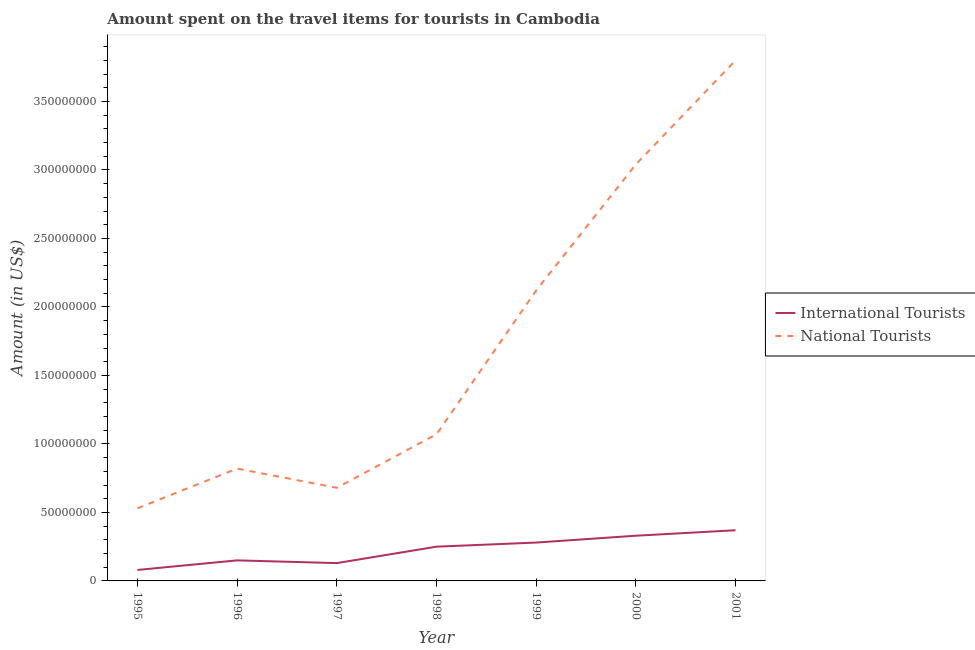How many different coloured lines are there?
Keep it short and to the point. 2. What is the amount spent on travel items of national tourists in 2001?
Offer a very short reply. 3.80e+08. Across all years, what is the maximum amount spent on travel items of national tourists?
Provide a succinct answer. 3.80e+08. Across all years, what is the minimum amount spent on travel items of international tourists?
Provide a short and direct response. 8.00e+06. In which year was the amount spent on travel items of national tourists maximum?
Offer a terse response. 2001. In which year was the amount spent on travel items of international tourists minimum?
Offer a very short reply. 1995. What is the total amount spent on travel items of national tourists in the graph?
Keep it short and to the point. 1.21e+09. What is the difference between the amount spent on travel items of international tourists in 1996 and that in 2000?
Keep it short and to the point. -1.80e+07. What is the difference between the amount spent on travel items of national tourists in 1998 and the amount spent on travel items of international tourists in 1996?
Your answer should be very brief. 9.20e+07. What is the average amount spent on travel items of international tourists per year?
Provide a succinct answer. 2.27e+07. In the year 1999, what is the difference between the amount spent on travel items of international tourists and amount spent on travel items of national tourists?
Ensure brevity in your answer.  -1.84e+08. What is the ratio of the amount spent on travel items of international tourists in 1997 to that in 2001?
Your response must be concise. 0.35. Is the amount spent on travel items of international tourists in 1995 less than that in 1998?
Ensure brevity in your answer.  Yes. Is the difference between the amount spent on travel items of international tourists in 1997 and 2001 greater than the difference between the amount spent on travel items of national tourists in 1997 and 2001?
Ensure brevity in your answer.  Yes. What is the difference between the highest and the second highest amount spent on travel items of international tourists?
Ensure brevity in your answer.  4.00e+06. What is the difference between the highest and the lowest amount spent on travel items of national tourists?
Provide a succinct answer. 3.27e+08. In how many years, is the amount spent on travel items of national tourists greater than the average amount spent on travel items of national tourists taken over all years?
Keep it short and to the point. 3. Does the amount spent on travel items of national tourists monotonically increase over the years?
Your answer should be very brief. No. Is the amount spent on travel items of international tourists strictly greater than the amount spent on travel items of national tourists over the years?
Your response must be concise. No. Is the amount spent on travel items of international tourists strictly less than the amount spent on travel items of national tourists over the years?
Your answer should be compact. Yes. How many lines are there?
Provide a succinct answer. 2. How many years are there in the graph?
Your response must be concise. 7. Where does the legend appear in the graph?
Your answer should be compact. Center right. How many legend labels are there?
Keep it short and to the point. 2. What is the title of the graph?
Ensure brevity in your answer.  Amount spent on the travel items for tourists in Cambodia. Does "From Government" appear as one of the legend labels in the graph?
Offer a terse response. No. What is the label or title of the X-axis?
Ensure brevity in your answer.  Year. What is the label or title of the Y-axis?
Make the answer very short. Amount (in US$). What is the Amount (in US$) of National Tourists in 1995?
Give a very brief answer. 5.30e+07. What is the Amount (in US$) in International Tourists in 1996?
Your answer should be very brief. 1.50e+07. What is the Amount (in US$) in National Tourists in 1996?
Ensure brevity in your answer.  8.20e+07. What is the Amount (in US$) of International Tourists in 1997?
Give a very brief answer. 1.30e+07. What is the Amount (in US$) of National Tourists in 1997?
Your answer should be very brief. 6.80e+07. What is the Amount (in US$) in International Tourists in 1998?
Your response must be concise. 2.50e+07. What is the Amount (in US$) in National Tourists in 1998?
Provide a short and direct response. 1.07e+08. What is the Amount (in US$) in International Tourists in 1999?
Provide a short and direct response. 2.80e+07. What is the Amount (in US$) of National Tourists in 1999?
Keep it short and to the point. 2.12e+08. What is the Amount (in US$) of International Tourists in 2000?
Your answer should be very brief. 3.30e+07. What is the Amount (in US$) in National Tourists in 2000?
Your answer should be very brief. 3.04e+08. What is the Amount (in US$) of International Tourists in 2001?
Make the answer very short. 3.70e+07. What is the Amount (in US$) of National Tourists in 2001?
Make the answer very short. 3.80e+08. Across all years, what is the maximum Amount (in US$) of International Tourists?
Your response must be concise. 3.70e+07. Across all years, what is the maximum Amount (in US$) in National Tourists?
Keep it short and to the point. 3.80e+08. Across all years, what is the minimum Amount (in US$) in International Tourists?
Your answer should be very brief. 8.00e+06. Across all years, what is the minimum Amount (in US$) of National Tourists?
Keep it short and to the point. 5.30e+07. What is the total Amount (in US$) of International Tourists in the graph?
Keep it short and to the point. 1.59e+08. What is the total Amount (in US$) in National Tourists in the graph?
Your response must be concise. 1.21e+09. What is the difference between the Amount (in US$) of International Tourists in 1995 and that in 1996?
Your response must be concise. -7.00e+06. What is the difference between the Amount (in US$) in National Tourists in 1995 and that in 1996?
Give a very brief answer. -2.90e+07. What is the difference between the Amount (in US$) in International Tourists in 1995 and that in 1997?
Make the answer very short. -5.00e+06. What is the difference between the Amount (in US$) of National Tourists in 1995 and that in 1997?
Ensure brevity in your answer.  -1.50e+07. What is the difference between the Amount (in US$) in International Tourists in 1995 and that in 1998?
Provide a succinct answer. -1.70e+07. What is the difference between the Amount (in US$) in National Tourists in 1995 and that in 1998?
Ensure brevity in your answer.  -5.40e+07. What is the difference between the Amount (in US$) of International Tourists in 1995 and that in 1999?
Ensure brevity in your answer.  -2.00e+07. What is the difference between the Amount (in US$) in National Tourists in 1995 and that in 1999?
Ensure brevity in your answer.  -1.59e+08. What is the difference between the Amount (in US$) of International Tourists in 1995 and that in 2000?
Give a very brief answer. -2.50e+07. What is the difference between the Amount (in US$) of National Tourists in 1995 and that in 2000?
Provide a short and direct response. -2.51e+08. What is the difference between the Amount (in US$) of International Tourists in 1995 and that in 2001?
Give a very brief answer. -2.90e+07. What is the difference between the Amount (in US$) of National Tourists in 1995 and that in 2001?
Your answer should be very brief. -3.27e+08. What is the difference between the Amount (in US$) of International Tourists in 1996 and that in 1997?
Offer a terse response. 2.00e+06. What is the difference between the Amount (in US$) in National Tourists in 1996 and that in 1997?
Keep it short and to the point. 1.40e+07. What is the difference between the Amount (in US$) in International Tourists in 1996 and that in 1998?
Provide a succinct answer. -1.00e+07. What is the difference between the Amount (in US$) in National Tourists in 1996 and that in 1998?
Give a very brief answer. -2.50e+07. What is the difference between the Amount (in US$) in International Tourists in 1996 and that in 1999?
Give a very brief answer. -1.30e+07. What is the difference between the Amount (in US$) in National Tourists in 1996 and that in 1999?
Make the answer very short. -1.30e+08. What is the difference between the Amount (in US$) in International Tourists in 1996 and that in 2000?
Your response must be concise. -1.80e+07. What is the difference between the Amount (in US$) of National Tourists in 1996 and that in 2000?
Provide a short and direct response. -2.22e+08. What is the difference between the Amount (in US$) of International Tourists in 1996 and that in 2001?
Offer a very short reply. -2.20e+07. What is the difference between the Amount (in US$) in National Tourists in 1996 and that in 2001?
Your answer should be compact. -2.98e+08. What is the difference between the Amount (in US$) of International Tourists in 1997 and that in 1998?
Ensure brevity in your answer.  -1.20e+07. What is the difference between the Amount (in US$) in National Tourists in 1997 and that in 1998?
Give a very brief answer. -3.90e+07. What is the difference between the Amount (in US$) of International Tourists in 1997 and that in 1999?
Keep it short and to the point. -1.50e+07. What is the difference between the Amount (in US$) of National Tourists in 1997 and that in 1999?
Your answer should be very brief. -1.44e+08. What is the difference between the Amount (in US$) of International Tourists in 1997 and that in 2000?
Give a very brief answer. -2.00e+07. What is the difference between the Amount (in US$) of National Tourists in 1997 and that in 2000?
Provide a succinct answer. -2.36e+08. What is the difference between the Amount (in US$) in International Tourists in 1997 and that in 2001?
Your answer should be very brief. -2.40e+07. What is the difference between the Amount (in US$) in National Tourists in 1997 and that in 2001?
Ensure brevity in your answer.  -3.12e+08. What is the difference between the Amount (in US$) in National Tourists in 1998 and that in 1999?
Ensure brevity in your answer.  -1.05e+08. What is the difference between the Amount (in US$) of International Tourists in 1998 and that in 2000?
Your answer should be very brief. -8.00e+06. What is the difference between the Amount (in US$) in National Tourists in 1998 and that in 2000?
Give a very brief answer. -1.97e+08. What is the difference between the Amount (in US$) in International Tourists in 1998 and that in 2001?
Your answer should be very brief. -1.20e+07. What is the difference between the Amount (in US$) in National Tourists in 1998 and that in 2001?
Your response must be concise. -2.73e+08. What is the difference between the Amount (in US$) of International Tourists in 1999 and that in 2000?
Give a very brief answer. -5.00e+06. What is the difference between the Amount (in US$) in National Tourists in 1999 and that in 2000?
Keep it short and to the point. -9.20e+07. What is the difference between the Amount (in US$) of International Tourists in 1999 and that in 2001?
Provide a succinct answer. -9.00e+06. What is the difference between the Amount (in US$) of National Tourists in 1999 and that in 2001?
Keep it short and to the point. -1.68e+08. What is the difference between the Amount (in US$) in National Tourists in 2000 and that in 2001?
Offer a terse response. -7.60e+07. What is the difference between the Amount (in US$) of International Tourists in 1995 and the Amount (in US$) of National Tourists in 1996?
Provide a short and direct response. -7.40e+07. What is the difference between the Amount (in US$) of International Tourists in 1995 and the Amount (in US$) of National Tourists in 1997?
Provide a short and direct response. -6.00e+07. What is the difference between the Amount (in US$) of International Tourists in 1995 and the Amount (in US$) of National Tourists in 1998?
Offer a very short reply. -9.90e+07. What is the difference between the Amount (in US$) of International Tourists in 1995 and the Amount (in US$) of National Tourists in 1999?
Ensure brevity in your answer.  -2.04e+08. What is the difference between the Amount (in US$) in International Tourists in 1995 and the Amount (in US$) in National Tourists in 2000?
Provide a succinct answer. -2.96e+08. What is the difference between the Amount (in US$) of International Tourists in 1995 and the Amount (in US$) of National Tourists in 2001?
Your answer should be compact. -3.72e+08. What is the difference between the Amount (in US$) in International Tourists in 1996 and the Amount (in US$) in National Tourists in 1997?
Your answer should be very brief. -5.30e+07. What is the difference between the Amount (in US$) in International Tourists in 1996 and the Amount (in US$) in National Tourists in 1998?
Your answer should be very brief. -9.20e+07. What is the difference between the Amount (in US$) of International Tourists in 1996 and the Amount (in US$) of National Tourists in 1999?
Make the answer very short. -1.97e+08. What is the difference between the Amount (in US$) in International Tourists in 1996 and the Amount (in US$) in National Tourists in 2000?
Your response must be concise. -2.89e+08. What is the difference between the Amount (in US$) in International Tourists in 1996 and the Amount (in US$) in National Tourists in 2001?
Keep it short and to the point. -3.65e+08. What is the difference between the Amount (in US$) in International Tourists in 1997 and the Amount (in US$) in National Tourists in 1998?
Provide a short and direct response. -9.40e+07. What is the difference between the Amount (in US$) of International Tourists in 1997 and the Amount (in US$) of National Tourists in 1999?
Keep it short and to the point. -1.99e+08. What is the difference between the Amount (in US$) of International Tourists in 1997 and the Amount (in US$) of National Tourists in 2000?
Ensure brevity in your answer.  -2.91e+08. What is the difference between the Amount (in US$) in International Tourists in 1997 and the Amount (in US$) in National Tourists in 2001?
Make the answer very short. -3.67e+08. What is the difference between the Amount (in US$) in International Tourists in 1998 and the Amount (in US$) in National Tourists in 1999?
Provide a succinct answer. -1.87e+08. What is the difference between the Amount (in US$) in International Tourists in 1998 and the Amount (in US$) in National Tourists in 2000?
Your response must be concise. -2.79e+08. What is the difference between the Amount (in US$) of International Tourists in 1998 and the Amount (in US$) of National Tourists in 2001?
Your response must be concise. -3.55e+08. What is the difference between the Amount (in US$) in International Tourists in 1999 and the Amount (in US$) in National Tourists in 2000?
Offer a terse response. -2.76e+08. What is the difference between the Amount (in US$) in International Tourists in 1999 and the Amount (in US$) in National Tourists in 2001?
Your answer should be compact. -3.52e+08. What is the difference between the Amount (in US$) of International Tourists in 2000 and the Amount (in US$) of National Tourists in 2001?
Offer a terse response. -3.47e+08. What is the average Amount (in US$) in International Tourists per year?
Offer a terse response. 2.27e+07. What is the average Amount (in US$) of National Tourists per year?
Provide a short and direct response. 1.72e+08. In the year 1995, what is the difference between the Amount (in US$) of International Tourists and Amount (in US$) of National Tourists?
Offer a terse response. -4.50e+07. In the year 1996, what is the difference between the Amount (in US$) in International Tourists and Amount (in US$) in National Tourists?
Your response must be concise. -6.70e+07. In the year 1997, what is the difference between the Amount (in US$) in International Tourists and Amount (in US$) in National Tourists?
Keep it short and to the point. -5.50e+07. In the year 1998, what is the difference between the Amount (in US$) of International Tourists and Amount (in US$) of National Tourists?
Offer a very short reply. -8.20e+07. In the year 1999, what is the difference between the Amount (in US$) in International Tourists and Amount (in US$) in National Tourists?
Your answer should be very brief. -1.84e+08. In the year 2000, what is the difference between the Amount (in US$) of International Tourists and Amount (in US$) of National Tourists?
Your answer should be compact. -2.71e+08. In the year 2001, what is the difference between the Amount (in US$) of International Tourists and Amount (in US$) of National Tourists?
Your answer should be very brief. -3.43e+08. What is the ratio of the Amount (in US$) of International Tourists in 1995 to that in 1996?
Offer a very short reply. 0.53. What is the ratio of the Amount (in US$) of National Tourists in 1995 to that in 1996?
Your answer should be compact. 0.65. What is the ratio of the Amount (in US$) of International Tourists in 1995 to that in 1997?
Ensure brevity in your answer.  0.62. What is the ratio of the Amount (in US$) in National Tourists in 1995 to that in 1997?
Provide a short and direct response. 0.78. What is the ratio of the Amount (in US$) of International Tourists in 1995 to that in 1998?
Your answer should be compact. 0.32. What is the ratio of the Amount (in US$) of National Tourists in 1995 to that in 1998?
Your answer should be very brief. 0.5. What is the ratio of the Amount (in US$) in International Tourists in 1995 to that in 1999?
Offer a very short reply. 0.29. What is the ratio of the Amount (in US$) in National Tourists in 1995 to that in 1999?
Your response must be concise. 0.25. What is the ratio of the Amount (in US$) of International Tourists in 1995 to that in 2000?
Your response must be concise. 0.24. What is the ratio of the Amount (in US$) of National Tourists in 1995 to that in 2000?
Offer a terse response. 0.17. What is the ratio of the Amount (in US$) of International Tourists in 1995 to that in 2001?
Your response must be concise. 0.22. What is the ratio of the Amount (in US$) in National Tourists in 1995 to that in 2001?
Offer a terse response. 0.14. What is the ratio of the Amount (in US$) in International Tourists in 1996 to that in 1997?
Offer a terse response. 1.15. What is the ratio of the Amount (in US$) of National Tourists in 1996 to that in 1997?
Make the answer very short. 1.21. What is the ratio of the Amount (in US$) of National Tourists in 1996 to that in 1998?
Your answer should be compact. 0.77. What is the ratio of the Amount (in US$) of International Tourists in 1996 to that in 1999?
Provide a short and direct response. 0.54. What is the ratio of the Amount (in US$) of National Tourists in 1996 to that in 1999?
Make the answer very short. 0.39. What is the ratio of the Amount (in US$) in International Tourists in 1996 to that in 2000?
Provide a succinct answer. 0.45. What is the ratio of the Amount (in US$) in National Tourists in 1996 to that in 2000?
Provide a short and direct response. 0.27. What is the ratio of the Amount (in US$) in International Tourists in 1996 to that in 2001?
Your answer should be compact. 0.41. What is the ratio of the Amount (in US$) in National Tourists in 1996 to that in 2001?
Offer a terse response. 0.22. What is the ratio of the Amount (in US$) of International Tourists in 1997 to that in 1998?
Give a very brief answer. 0.52. What is the ratio of the Amount (in US$) in National Tourists in 1997 to that in 1998?
Offer a very short reply. 0.64. What is the ratio of the Amount (in US$) in International Tourists in 1997 to that in 1999?
Give a very brief answer. 0.46. What is the ratio of the Amount (in US$) of National Tourists in 1997 to that in 1999?
Provide a short and direct response. 0.32. What is the ratio of the Amount (in US$) in International Tourists in 1997 to that in 2000?
Offer a terse response. 0.39. What is the ratio of the Amount (in US$) of National Tourists in 1997 to that in 2000?
Offer a terse response. 0.22. What is the ratio of the Amount (in US$) in International Tourists in 1997 to that in 2001?
Your response must be concise. 0.35. What is the ratio of the Amount (in US$) in National Tourists in 1997 to that in 2001?
Your answer should be compact. 0.18. What is the ratio of the Amount (in US$) of International Tourists in 1998 to that in 1999?
Give a very brief answer. 0.89. What is the ratio of the Amount (in US$) of National Tourists in 1998 to that in 1999?
Ensure brevity in your answer.  0.5. What is the ratio of the Amount (in US$) in International Tourists in 1998 to that in 2000?
Provide a succinct answer. 0.76. What is the ratio of the Amount (in US$) in National Tourists in 1998 to that in 2000?
Give a very brief answer. 0.35. What is the ratio of the Amount (in US$) in International Tourists in 1998 to that in 2001?
Provide a succinct answer. 0.68. What is the ratio of the Amount (in US$) of National Tourists in 1998 to that in 2001?
Ensure brevity in your answer.  0.28. What is the ratio of the Amount (in US$) in International Tourists in 1999 to that in 2000?
Your answer should be very brief. 0.85. What is the ratio of the Amount (in US$) in National Tourists in 1999 to that in 2000?
Provide a short and direct response. 0.7. What is the ratio of the Amount (in US$) of International Tourists in 1999 to that in 2001?
Ensure brevity in your answer.  0.76. What is the ratio of the Amount (in US$) in National Tourists in 1999 to that in 2001?
Your response must be concise. 0.56. What is the ratio of the Amount (in US$) in International Tourists in 2000 to that in 2001?
Ensure brevity in your answer.  0.89. What is the ratio of the Amount (in US$) in National Tourists in 2000 to that in 2001?
Make the answer very short. 0.8. What is the difference between the highest and the second highest Amount (in US$) of National Tourists?
Your answer should be compact. 7.60e+07. What is the difference between the highest and the lowest Amount (in US$) of International Tourists?
Your answer should be compact. 2.90e+07. What is the difference between the highest and the lowest Amount (in US$) of National Tourists?
Ensure brevity in your answer.  3.27e+08. 